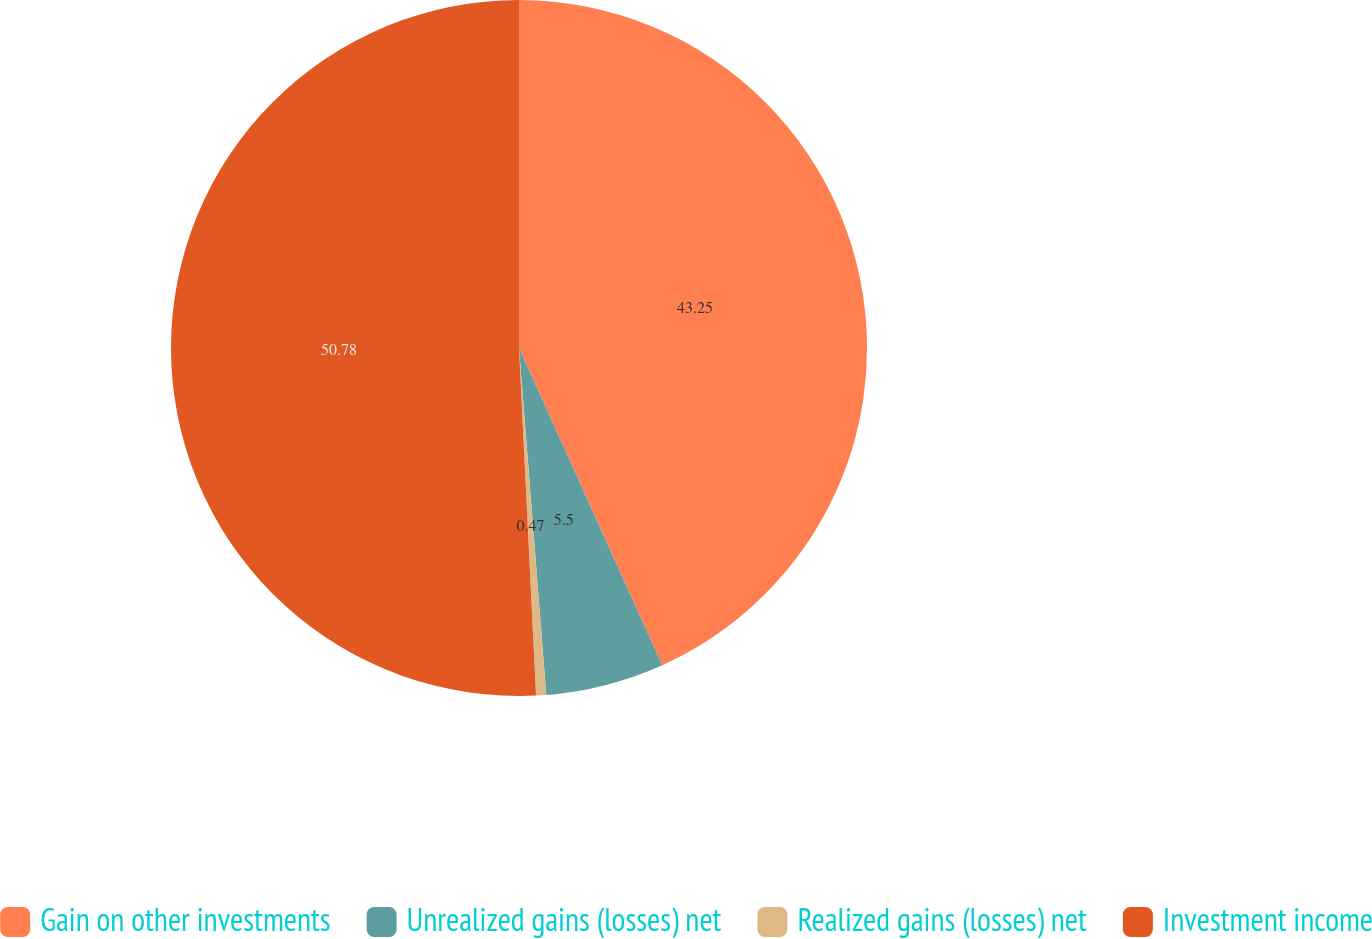<chart> <loc_0><loc_0><loc_500><loc_500><pie_chart><fcel>Gain on other investments<fcel>Unrealized gains (losses) net<fcel>Realized gains (losses) net<fcel>Investment income<nl><fcel>43.25%<fcel>5.5%<fcel>0.47%<fcel>50.78%<nl></chart> 